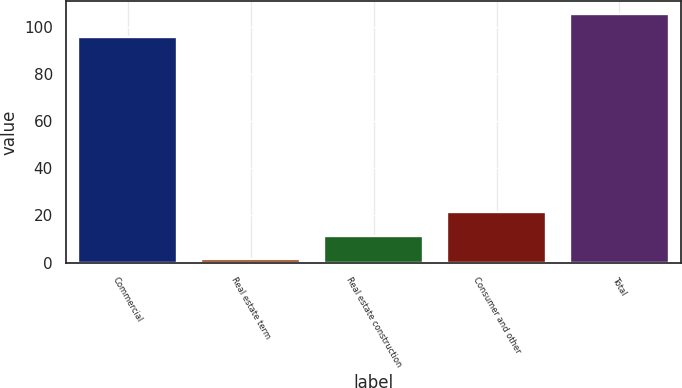<chart> <loc_0><loc_0><loc_500><loc_500><bar_chart><fcel>Commercial<fcel>Real estate term<fcel>Real estate construction<fcel>Consumer and other<fcel>Total<nl><fcel>95.5<fcel>1.5<fcel>11.35<fcel>21.2<fcel>105.35<nl></chart> 